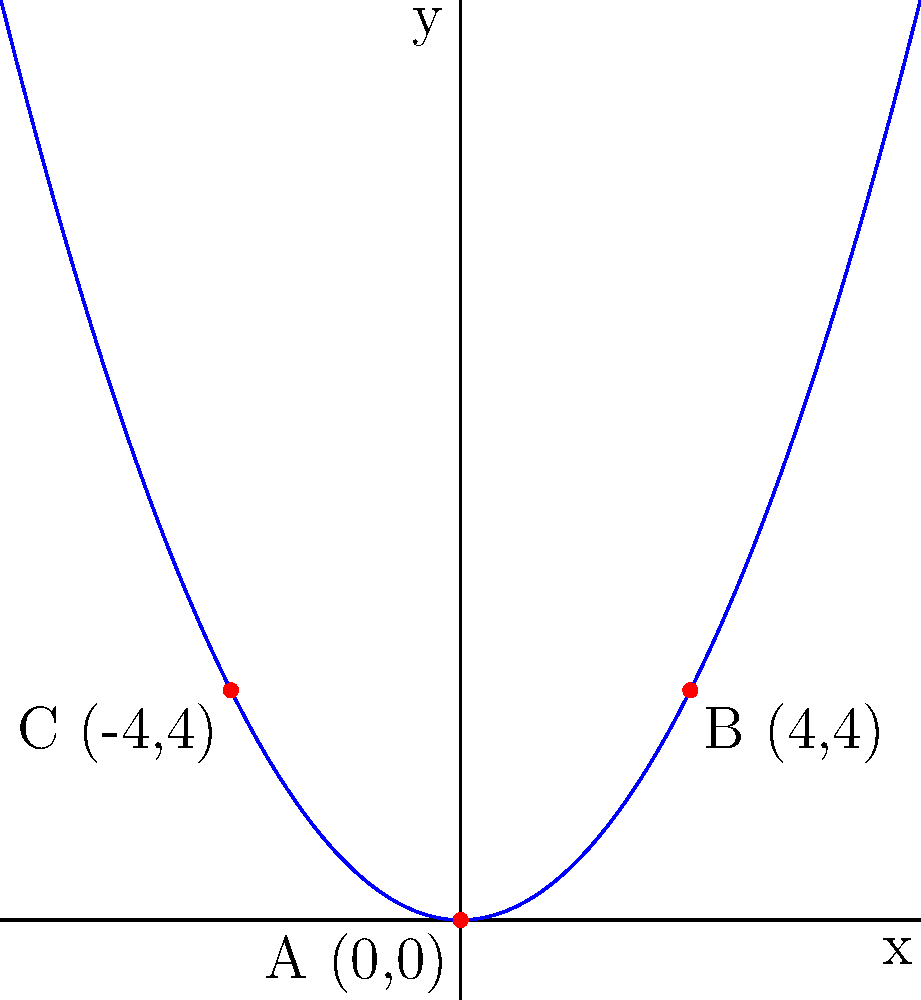In a retro platformer game, you're designing a level with a parabolic arc for a character to jump along. The arc passes through points A(0,0), B(4,4), and C(-4,4). Determine the equation of this parabolic arc in the form $y = ax^2 + bx + c$. To find the equation of the parabola, we'll follow these steps:

1) The general form of a parabola is $y = ax^2 + bx + c$.

2) Since the parabola passes through (0,0), we know that $c = 0$.

3) Now we have $y = ax^2 + bx$.

4) Using points B(4,4) and C(-4,4), we can create two equations:

   For B: $4 = a(4)^2 + b(4)$
   For C: $4 = a(-4)^2 + b(-4)$

5) Simplify:
   $4 = 16a + 4b$  (Equation 1)
   $4 = 16a - 4b$  (Equation 2)

6) Subtracting Equation 2 from Equation 1:
   $0 = 8b$
   $b = 0$

7) Substitute $b = 0$ into Equation 1:
   $4 = 16a$
   $a = 1/4 = 0.25$

8) Therefore, the equation of the parabola is $y = 0.25x^2$.

This equation represents a parabolic arc that opens upward and passes through the given points, perfect for a retro platformer jump trajectory.
Answer: $y = 0.25x^2$ 